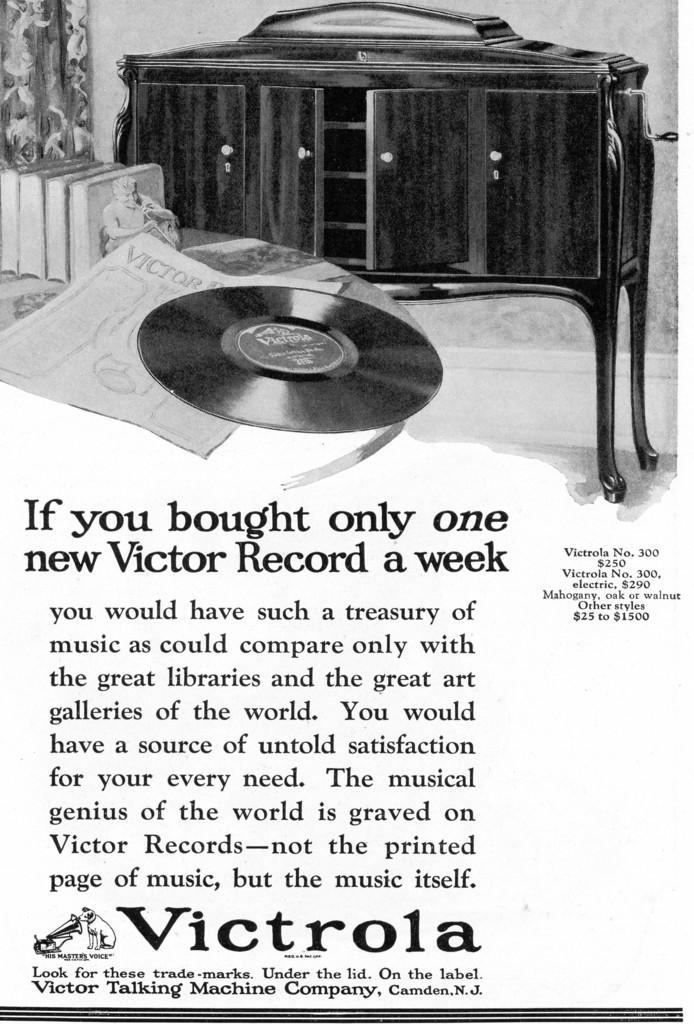How would you summarize this image in a sentence or two? In this picture I can observe a disc and a paper placed on the table along with some books. I can observe wooden cupboard. There is some text in this picture. The background is in white color. 